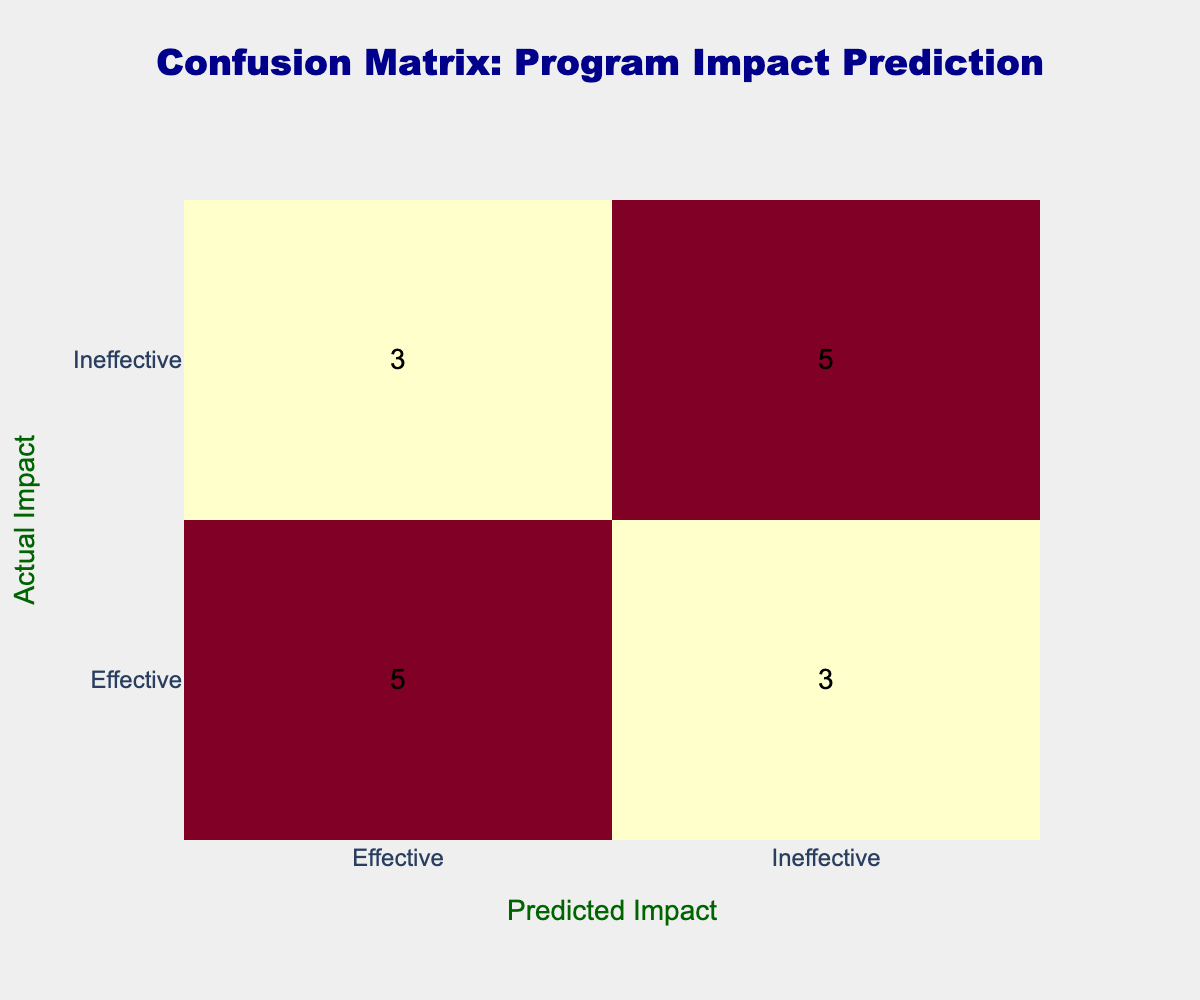What is the total number of times the program was predicted to be effective? By looking at the "Predicted Impact" column, I can count all instances where the predicted impact is "Effective". There are 7 occurrences of "Effective" under the "Predicted Impact".
Answer: 7 How many times did the program actually have an ineffective impact? In the "Actual Impact" column, I count the instances where the impact is marked "Ineffective". There are 7 occurrences of "Ineffective" under the "Actual Impact".
Answer: 7 What is the number of false negatives in this confusion matrix? False negatives occur when the actual impact is "Effective" but the predicted impact is "Ineffective". I find 3 instances in the table matching this condition.
Answer: 3 What is the total number of instances where the predicted impact was ineffective? I examine the "Predicted Impact" column for the count of "Ineffective". I find 5 occurrences of "Ineffective" under the "Predicted Impact".
Answer: 5 Is it true that the program was predicted to be ineffective more times than it was actually ineffective? I compare the counts of "Predicted Impact" being "Ineffective" (5 times) and "Actual Impact" being "Ineffective" (7 times). Since 5 is less than 7, the statement is false.
Answer: No What percentage of the predictions were correct? To find the percentage of correct predictions, I first identify the total predictions, which is 16. Next, I sum the diagonal elements in the confusion matrix, which equates to 9 correct predictions (4 effective correctly predicted + 5 ineffective correctly predicted). Thus, the accuracy is (9/16) * 100 = 56.25%.
Answer: 56.25% When both the actual and predicted impacts are effective, how many occurrences are there? I look for the element in the table where "Actual Impact" is "Effective" and "Predicted Impact" is also "Effective". There are 4 instances where this is the case.
Answer: 4 What is the difference between the number of true positives and true negatives? True positives are when both actual and predicted impacts are "Effective" (4 instances), and true negatives are when both actual and predicted impacts are "Ineffective" (5 instances). Thus, the difference is 4 - 5 = -1.
Answer: -1 